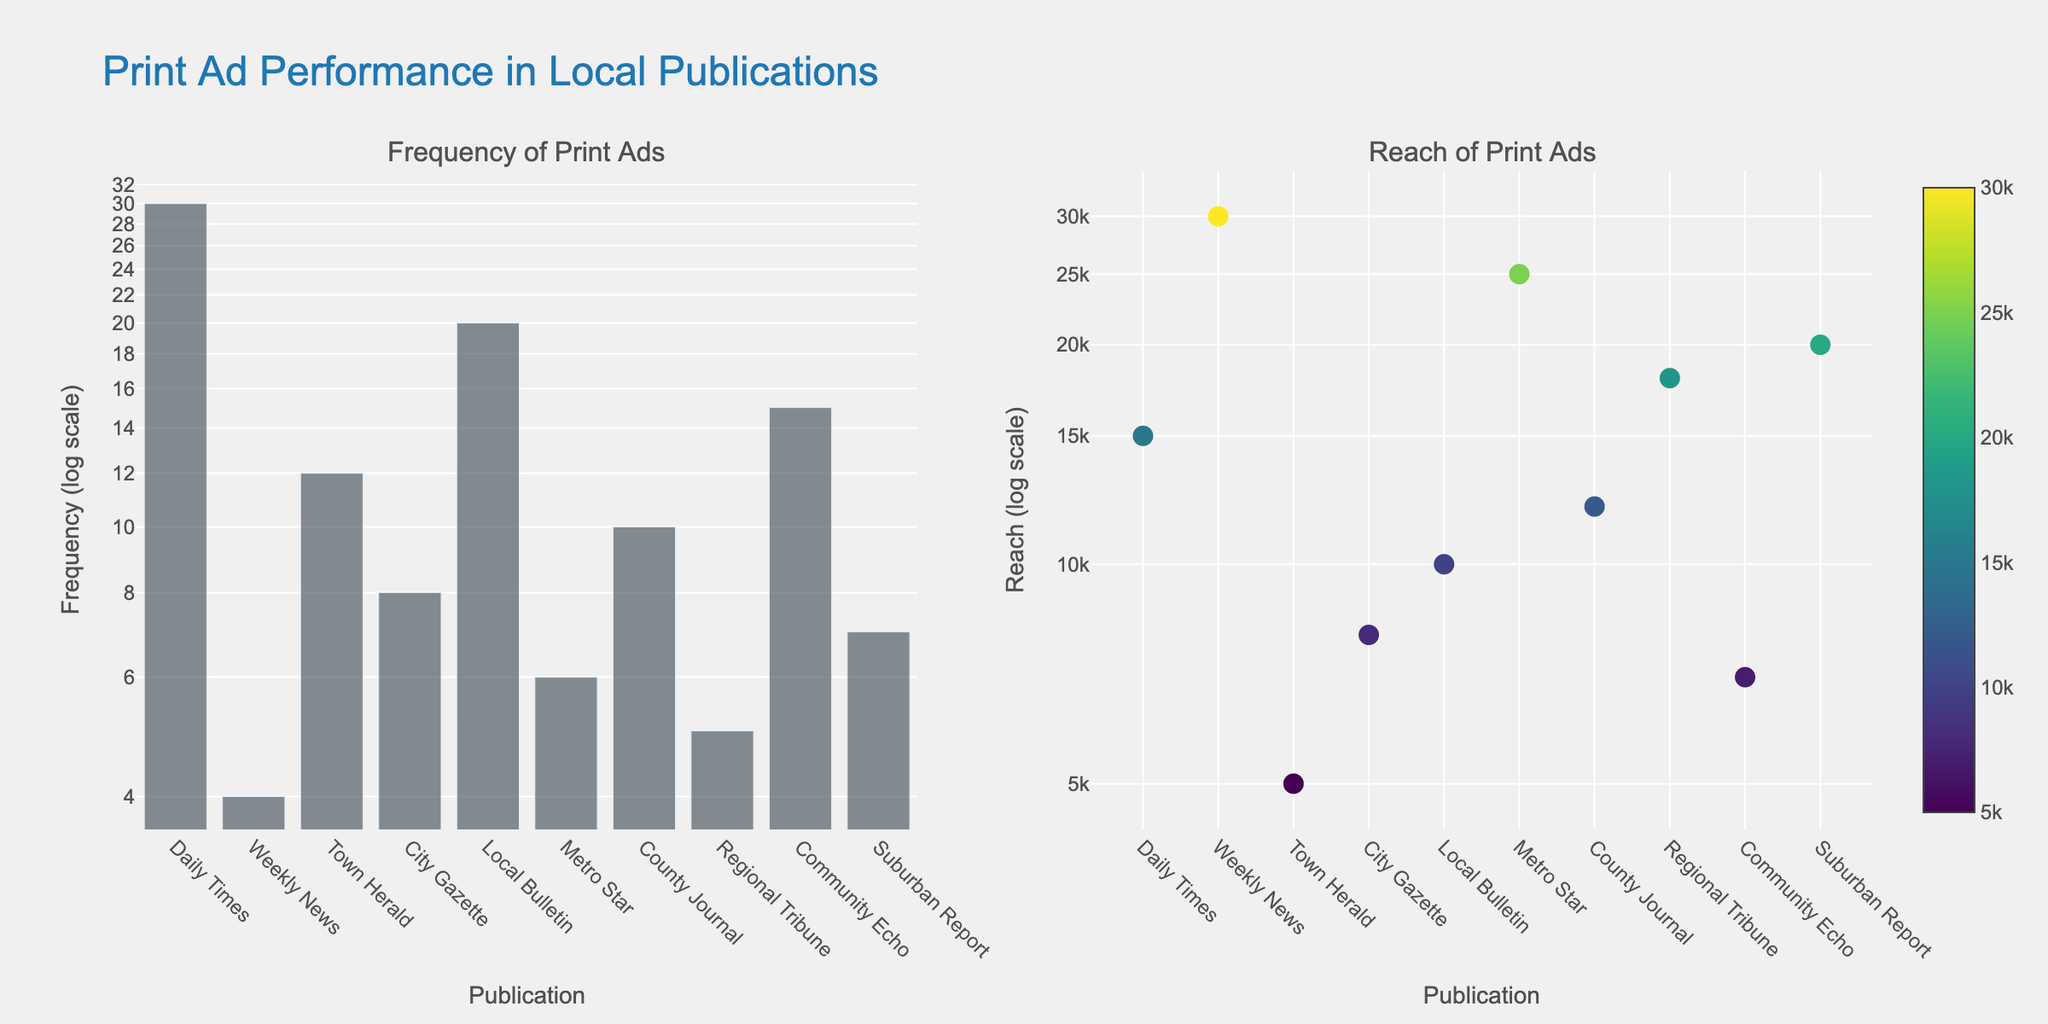What is the title of the figure? The title of the figure is displayed prominently at the top and reads "Print Ad Performance in Local Publications."
Answer: Print Ad Performance in Local Publications What does the y-axis represent in the left subplot? The y-axis in the left subplot represents the "Frequency" of print ads, displayed using a log scale, which is noted in the axis title.
Answer: Frequency (log scale) Which publication has the highest frequency of print ads? By looking at the height of the bars in the left subplot, "Daily Times" has the highest bar, indicating the highest frequency.
Answer: Daily Times How is the data for "Reach of Print Ads" represented in the right subplot? The data for reach is represented as scatter points. The size and color intensity of the points vary, with a color scale indicating different reach values.
Answer: Scatter points with size and color variations Which publication has the smallest reach, and what is its value? In the right subplot, the smallest scatter point corresponds to "Town Herald." The exact value for its reach, given by the hover info, is 5000.
Answer: Town Herald, 5000 How does the reach of "Metro Star" compare to "Suburban Report"? From the scatter points in the right subplot, "Metro Star" has a larger point than "Suburban Report," indicating a higher reach. The respective reach values are 25000 and 20000.
Answer: Metro Star has a higher reach What is the combined frequency of print ads for "Weekly News" and "City Gazette"? In the left subplot, the bar heights for "Weekly News" and "City Gazette" need to be added. The respective frequencies are 4 and 8. Adding them gives 4 + 8 = 12.
Answer: 12 What is the average reach of all publications? To find the average reach, sum the reach values of all publications (15000 + 30000 + 5000 + 8000 + 10000 + 25000 + 12000 + 18000 + 7000 + 20000) which equals 150,000 and divide by the number of publications, 10. So, 150,000 / 10 = 15000.
Answer: 15000 